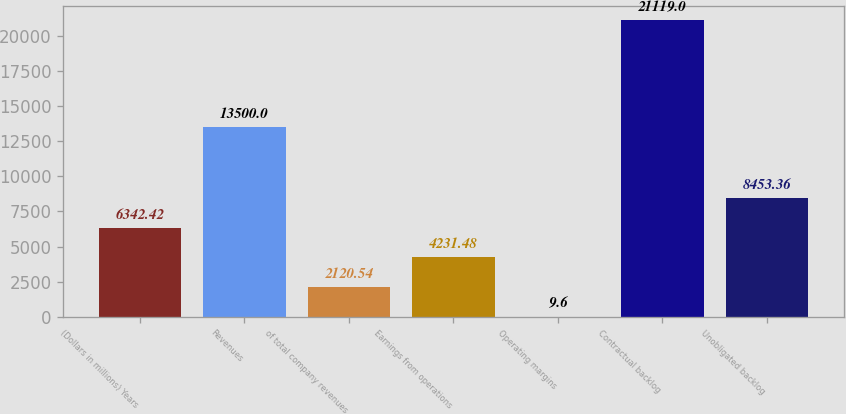<chart> <loc_0><loc_0><loc_500><loc_500><bar_chart><fcel>(Dollars in millions) Years<fcel>Revenues<fcel>of total company revenues<fcel>Earnings from operations<fcel>Operating margins<fcel>Contractual backlog<fcel>Unobligated backlog<nl><fcel>6342.42<fcel>13500<fcel>2120.54<fcel>4231.48<fcel>9.6<fcel>21119<fcel>8453.36<nl></chart> 